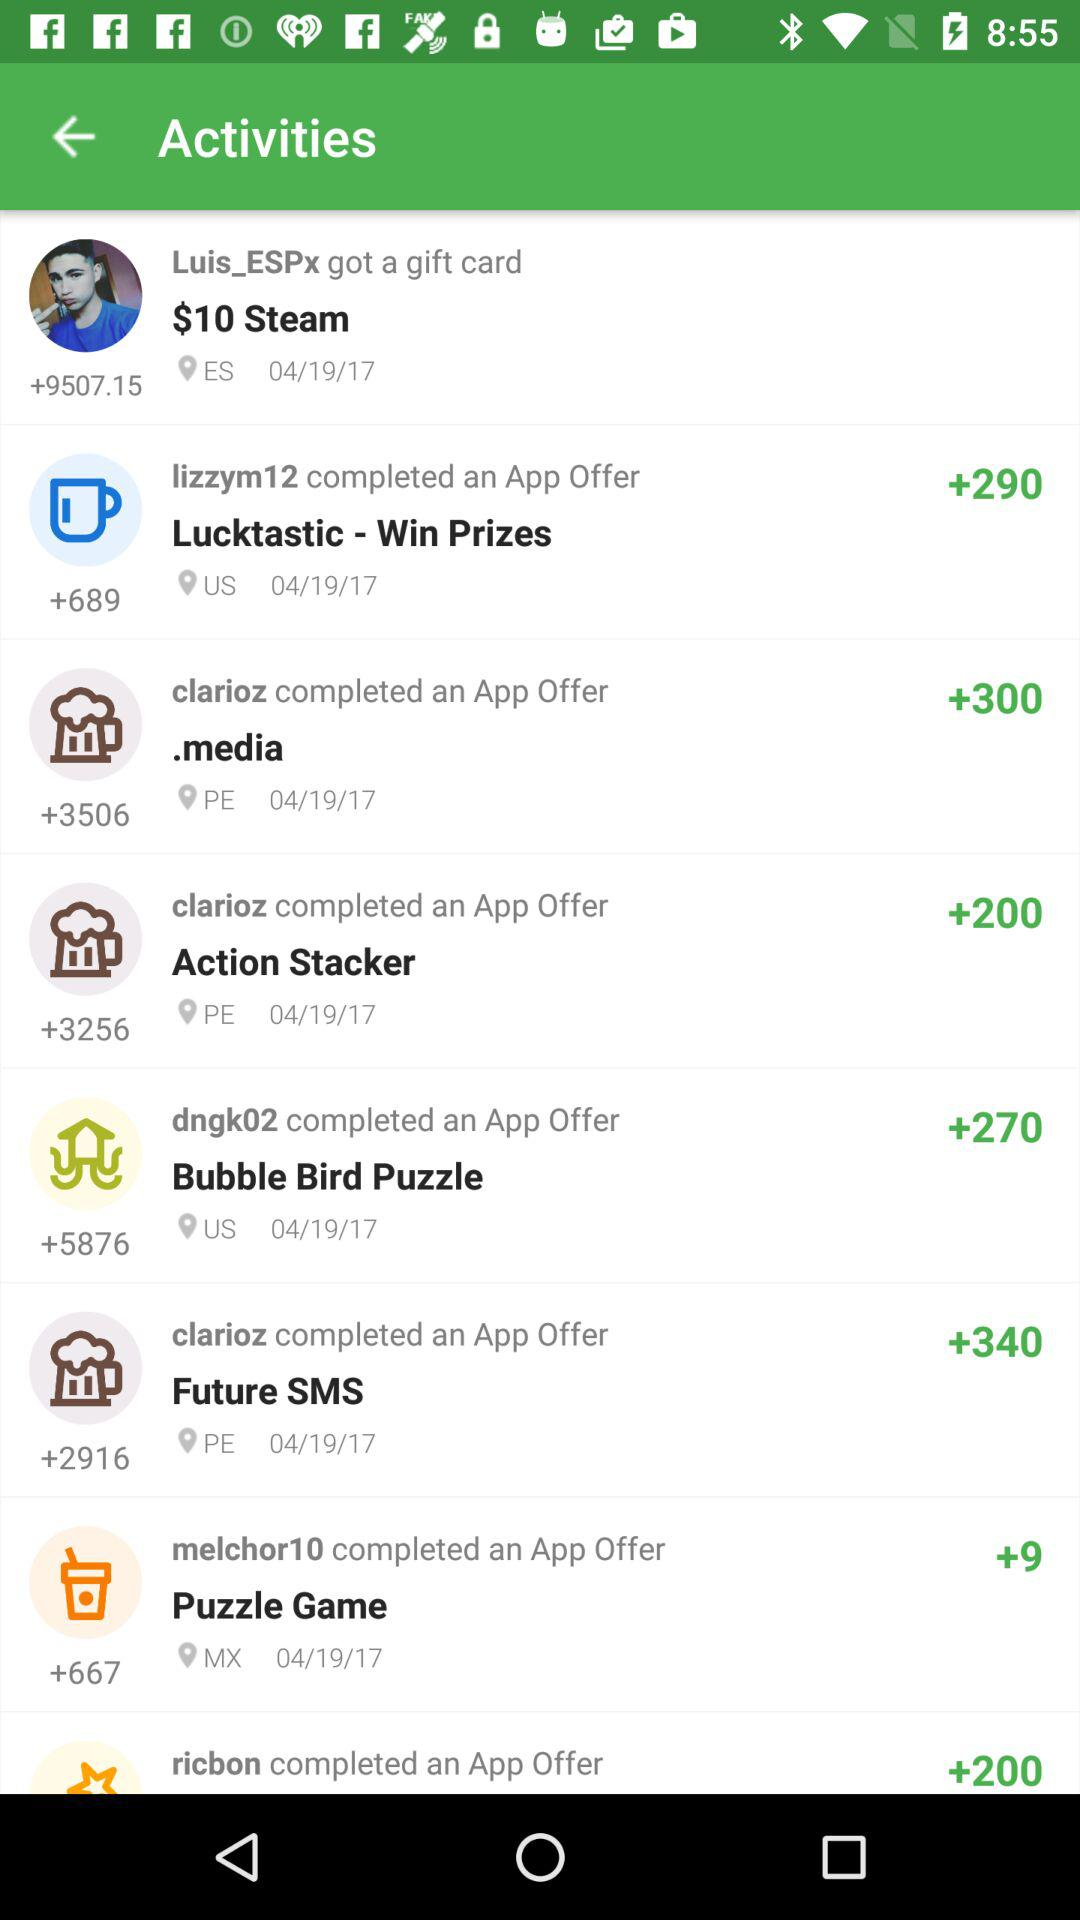What date is displayed on the screen? The displayed date is April 19, 2017. 